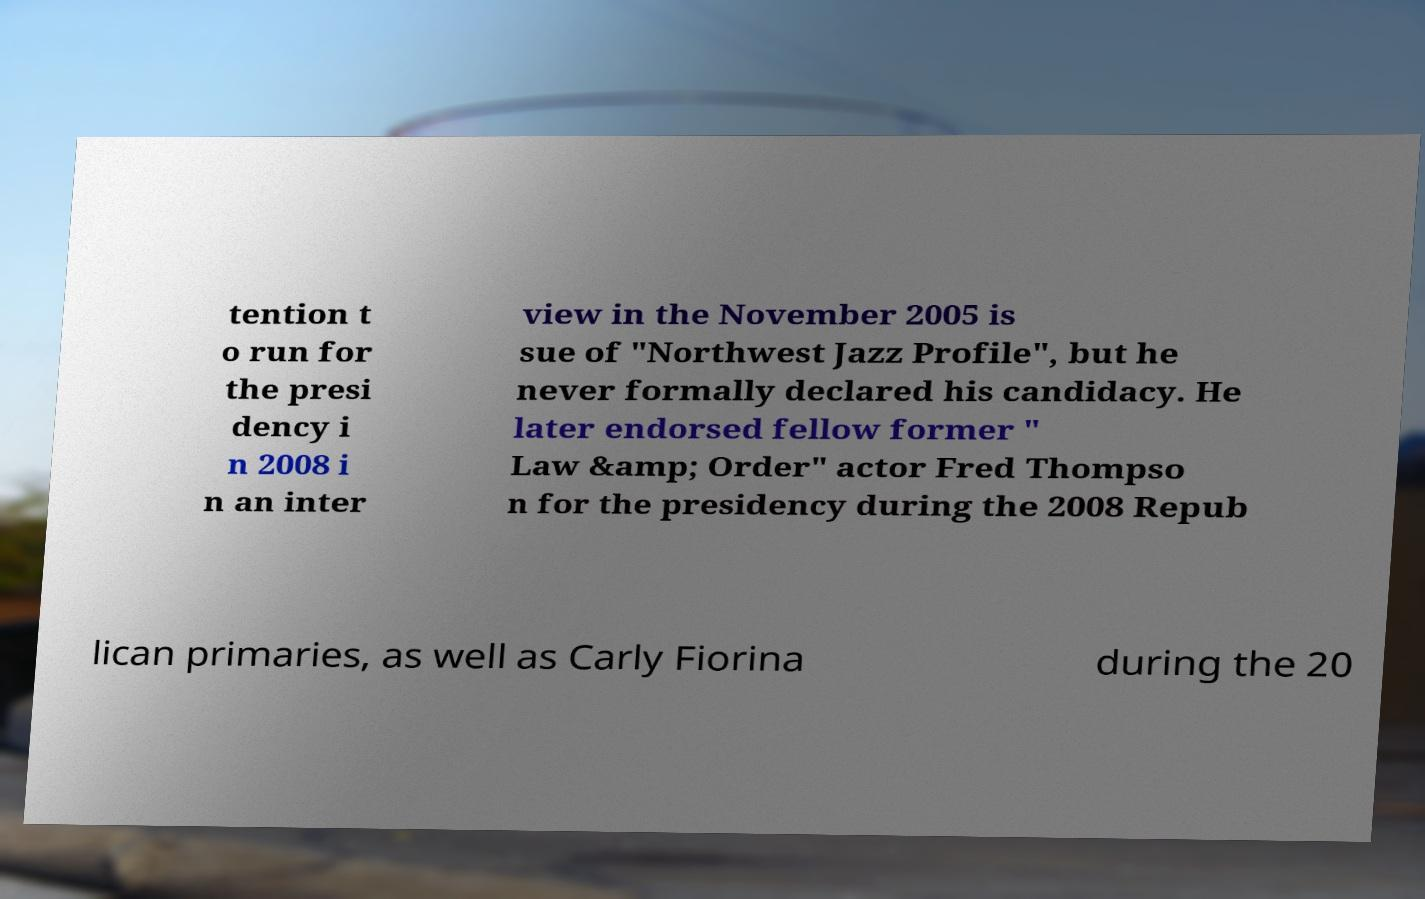What messages or text are displayed in this image? I need them in a readable, typed format. tention t o run for the presi dency i n 2008 i n an inter view in the November 2005 is sue of "Northwest Jazz Profile", but he never formally declared his candidacy. He later endorsed fellow former " Law &amp; Order" actor Fred Thompso n for the presidency during the 2008 Repub lican primaries, as well as Carly Fiorina during the 20 